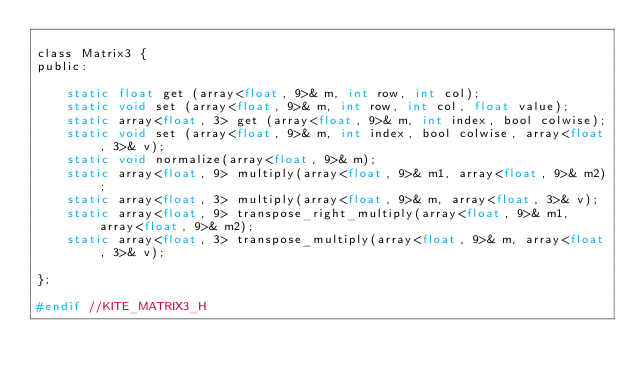<code> <loc_0><loc_0><loc_500><loc_500><_C_>
class Matrix3 {
public:

    static float get (array<float, 9>& m, int row, int col);
    static void set (array<float, 9>& m, int row, int col, float value);
    static array<float, 3> get (array<float, 9>& m, int index, bool colwise);
    static void set (array<float, 9>& m, int index, bool colwise, array<float, 3>& v);
    static void normalize(array<float, 9>& m);
    static array<float, 9> multiply(array<float, 9>& m1, array<float, 9>& m2);
    static array<float, 3> multiply(array<float, 9>& m, array<float, 3>& v);
    static array<float, 9> transpose_right_multiply(array<float, 9>& m1, array<float, 9>& m2);
    static array<float, 3> transpose_multiply(array<float, 9>& m, array<float, 3>& v);

};

#endif //KITE_MATRIX3_H
</code> 